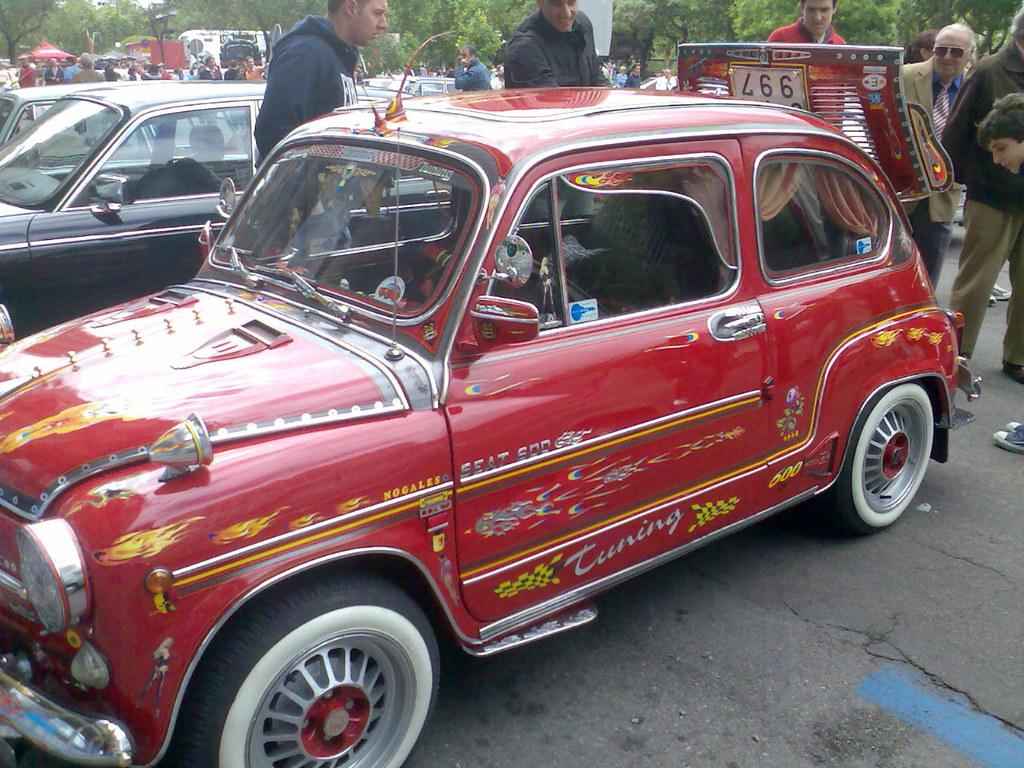<image>
Relay a brief, clear account of the picture shown. A red car with flames and Tuning written down the side with everyone looking at it. 